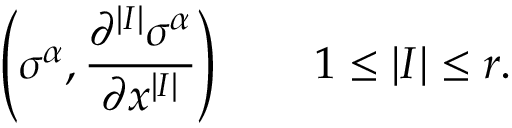<formula> <loc_0><loc_0><loc_500><loc_500>\left ( \sigma ^ { \alpha } , { \frac { \partial ^ { | I | } \sigma ^ { \alpha } } { \partial x ^ { | I | } } } \right ) \quad 1 \leq | I | \leq r .</formula> 